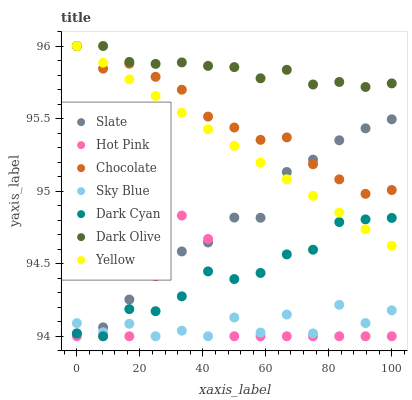Does Sky Blue have the minimum area under the curve?
Answer yes or no. Yes. Does Dark Olive have the maximum area under the curve?
Answer yes or no. Yes. Does Slate have the minimum area under the curve?
Answer yes or no. No. Does Slate have the maximum area under the curve?
Answer yes or no. No. Is Yellow the smoothest?
Answer yes or no. Yes. Is Sky Blue the roughest?
Answer yes or no. Yes. Is Slate the smoothest?
Answer yes or no. No. Is Slate the roughest?
Answer yes or no. No. Does Hot Pink have the lowest value?
Answer yes or no. Yes. Does Slate have the lowest value?
Answer yes or no. No. Does Chocolate have the highest value?
Answer yes or no. Yes. Does Slate have the highest value?
Answer yes or no. No. Is Hot Pink less than Yellow?
Answer yes or no. Yes. Is Dark Olive greater than Hot Pink?
Answer yes or no. Yes. Does Hot Pink intersect Slate?
Answer yes or no. Yes. Is Hot Pink less than Slate?
Answer yes or no. No. Is Hot Pink greater than Slate?
Answer yes or no. No. Does Hot Pink intersect Yellow?
Answer yes or no. No. 